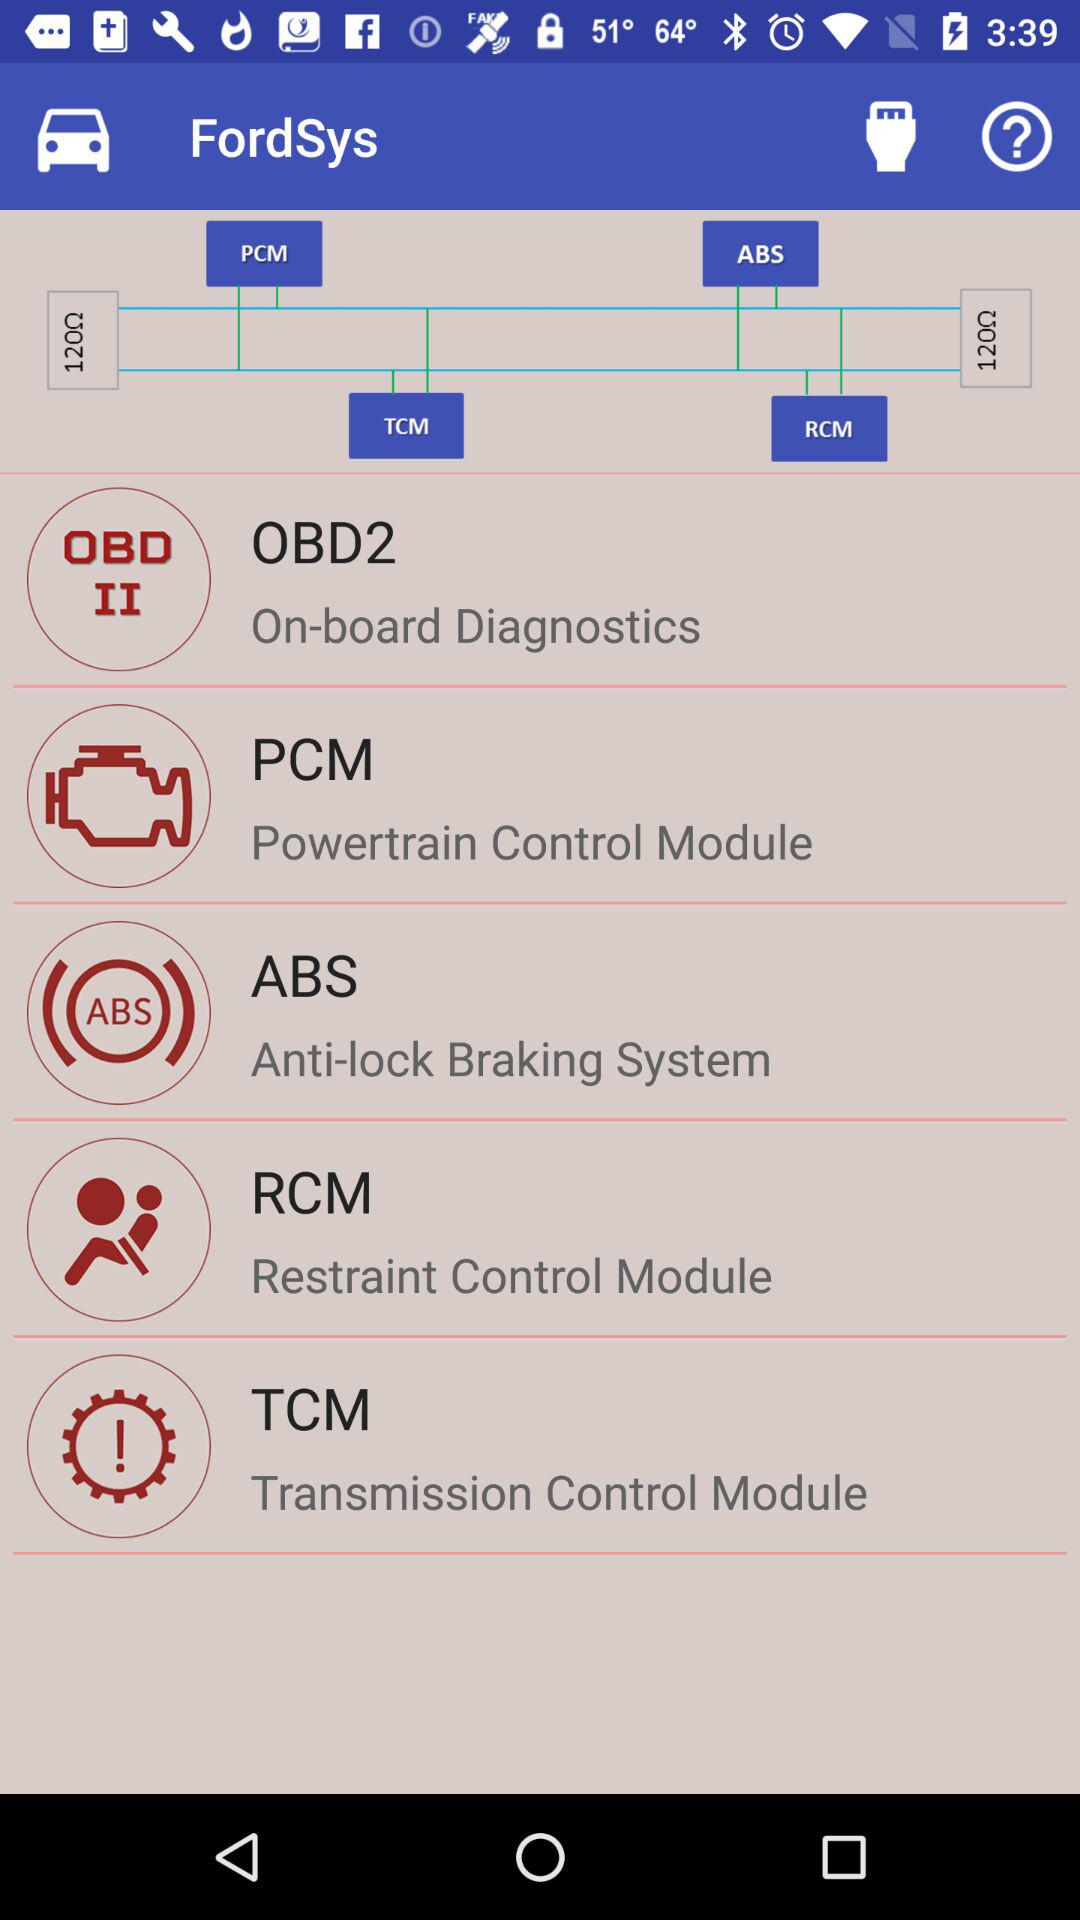What is the application name? The application name is "FordSys". 